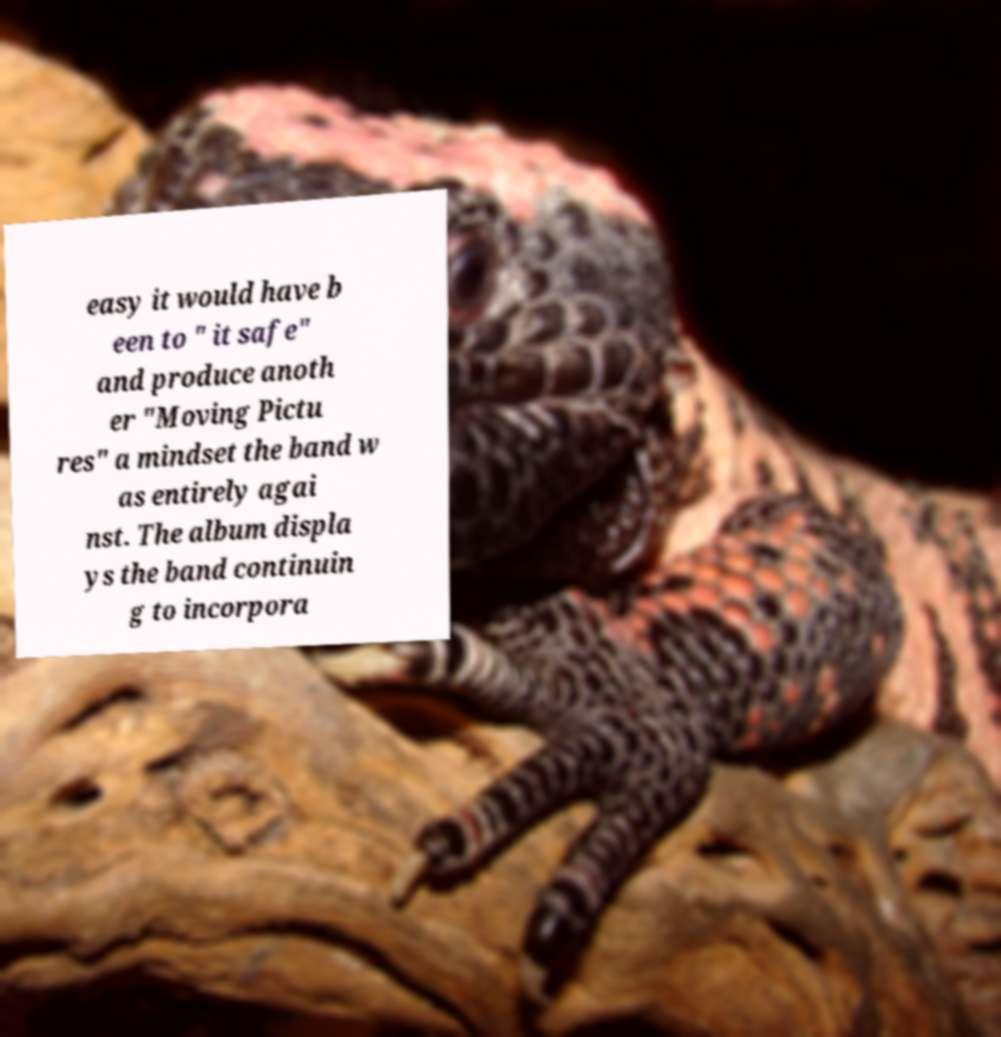Can you read and provide the text displayed in the image?This photo seems to have some interesting text. Can you extract and type it out for me? easy it would have b een to " it safe" and produce anoth er "Moving Pictu res" a mindset the band w as entirely agai nst. The album displa ys the band continuin g to incorpora 